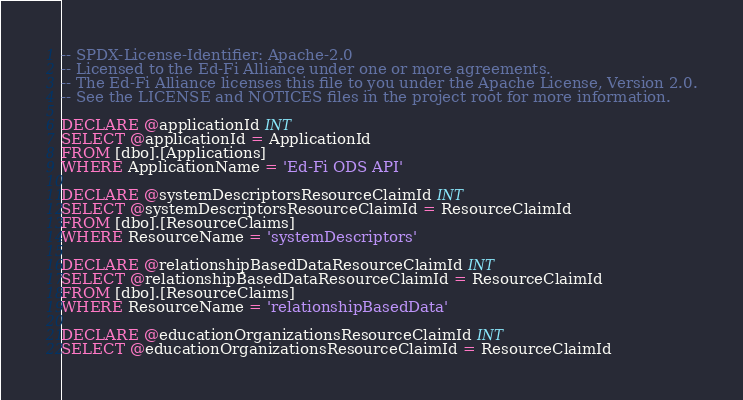<code> <loc_0><loc_0><loc_500><loc_500><_SQL_>-- SPDX-License-Identifier: Apache-2.0
-- Licensed to the Ed-Fi Alliance under one or more agreements.
-- The Ed-Fi Alliance licenses this file to you under the Apache License, Version 2.0.
-- See the LICENSE and NOTICES files in the project root for more information.

DECLARE @applicationId INT
SELECT @applicationId = ApplicationId
FROM [dbo].[Applications]
WHERE ApplicationName = 'Ed-Fi ODS API'

DECLARE @systemDescriptorsResourceClaimId INT
SELECT @systemDescriptorsResourceClaimId = ResourceClaimId
FROM [dbo].[ResourceClaims]
WHERE ResourceName = 'systemDescriptors'

DECLARE @relationshipBasedDataResourceClaimId INT
SELECT @relationshipBasedDataResourceClaimId = ResourceClaimId
FROM [dbo].[ResourceClaims]
WHERE ResourceName = 'relationshipBasedData'

DECLARE @educationOrganizationsResourceClaimId INT
SELECT @educationOrganizationsResourceClaimId = ResourceClaimId</code> 